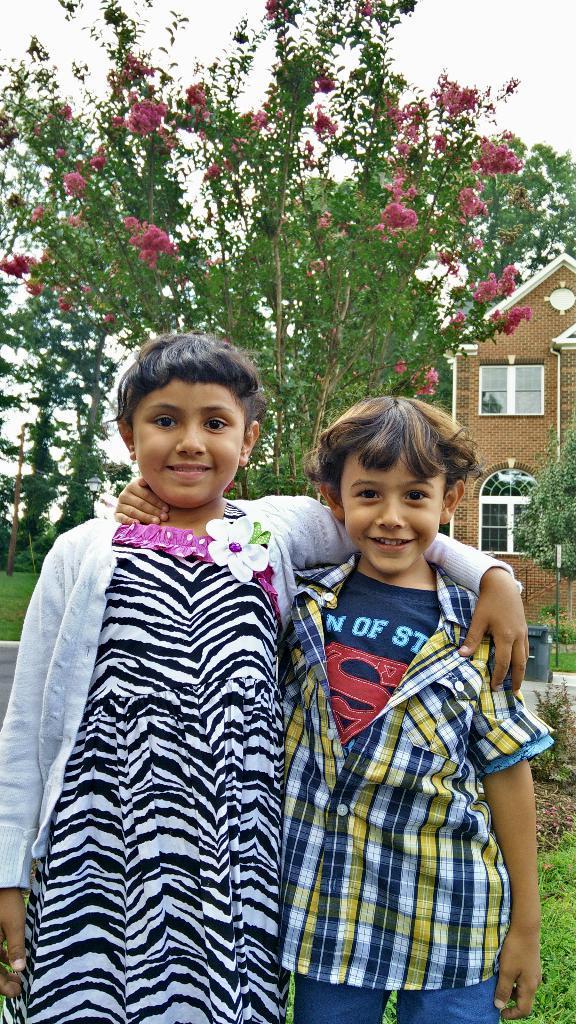Can you describe this image briefly? In this picture we can see a girl and a boy standing and smiling and at the back of them we can see a bin on the ground, grass, trees, flowers, building with windows and in the background we can see the sky. 